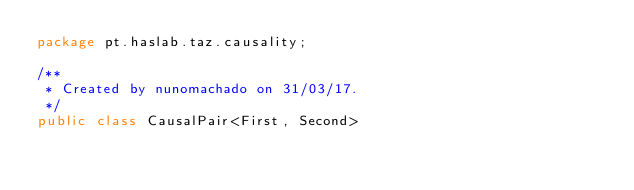Convert code to text. <code><loc_0><loc_0><loc_500><loc_500><_Java_>package pt.haslab.taz.causality;

/**
 * Created by nunomachado on 31/03/17.
 */
public class CausalPair<First, Second></code> 